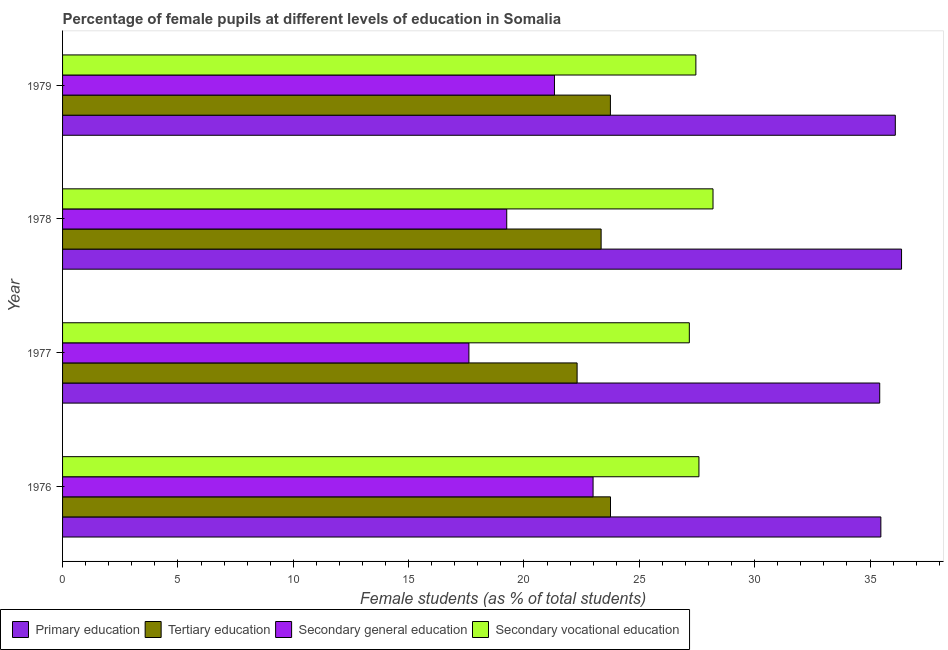How many different coloured bars are there?
Provide a short and direct response. 4. How many bars are there on the 3rd tick from the bottom?
Make the answer very short. 4. In how many cases, is the number of bars for a given year not equal to the number of legend labels?
Ensure brevity in your answer.  0. What is the percentage of female students in primary education in 1976?
Offer a very short reply. 35.47. Across all years, what is the maximum percentage of female students in primary education?
Give a very brief answer. 36.36. Across all years, what is the minimum percentage of female students in secondary vocational education?
Your answer should be compact. 27.17. In which year was the percentage of female students in primary education maximum?
Provide a succinct answer. 1978. What is the total percentage of female students in secondary vocational education in the graph?
Give a very brief answer. 110.39. What is the difference between the percentage of female students in secondary education in 1977 and that in 1979?
Your answer should be compact. -3.71. What is the difference between the percentage of female students in primary education in 1977 and the percentage of female students in tertiary education in 1976?
Keep it short and to the point. 11.67. What is the average percentage of female students in secondary education per year?
Offer a very short reply. 20.3. In the year 1976, what is the difference between the percentage of female students in secondary vocational education and percentage of female students in tertiary education?
Provide a succinct answer. 3.83. In how many years, is the percentage of female students in primary education greater than 26 %?
Your answer should be very brief. 4. What is the ratio of the percentage of female students in tertiary education in 1977 to that in 1978?
Provide a short and direct response. 0.95. Is the percentage of female students in primary education in 1977 less than that in 1978?
Provide a succinct answer. Yes. Is the difference between the percentage of female students in secondary education in 1976 and 1978 greater than the difference between the percentage of female students in secondary vocational education in 1976 and 1978?
Offer a terse response. Yes. What is the difference between the highest and the second highest percentage of female students in secondary vocational education?
Keep it short and to the point. 0.61. What is the difference between the highest and the lowest percentage of female students in secondary education?
Your response must be concise. 5.38. In how many years, is the percentage of female students in primary education greater than the average percentage of female students in primary education taken over all years?
Your response must be concise. 2. Is it the case that in every year, the sum of the percentage of female students in secondary education and percentage of female students in primary education is greater than the sum of percentage of female students in secondary vocational education and percentage of female students in tertiary education?
Keep it short and to the point. No. What does the 1st bar from the top in 1979 represents?
Ensure brevity in your answer.  Secondary vocational education. What does the 4th bar from the bottom in 1977 represents?
Provide a succinct answer. Secondary vocational education. How many years are there in the graph?
Keep it short and to the point. 4. What is the difference between two consecutive major ticks on the X-axis?
Provide a succinct answer. 5. Does the graph contain any zero values?
Your answer should be compact. No. Where does the legend appear in the graph?
Provide a succinct answer. Bottom left. How are the legend labels stacked?
Offer a terse response. Horizontal. What is the title of the graph?
Your response must be concise. Percentage of female pupils at different levels of education in Somalia. What is the label or title of the X-axis?
Provide a short and direct response. Female students (as % of total students). What is the Female students (as % of total students) in Primary education in 1976?
Give a very brief answer. 35.47. What is the Female students (as % of total students) of Tertiary education in 1976?
Make the answer very short. 23.75. What is the Female students (as % of total students) in Secondary general education in 1976?
Keep it short and to the point. 22.99. What is the Female students (as % of total students) in Secondary vocational education in 1976?
Offer a terse response. 27.58. What is the Female students (as % of total students) of Primary education in 1977?
Your answer should be very brief. 35.42. What is the Female students (as % of total students) of Tertiary education in 1977?
Ensure brevity in your answer.  22.3. What is the Female students (as % of total students) in Secondary general education in 1977?
Offer a very short reply. 17.61. What is the Female students (as % of total students) in Secondary vocational education in 1977?
Make the answer very short. 27.17. What is the Female students (as % of total students) in Primary education in 1978?
Give a very brief answer. 36.36. What is the Female students (as % of total students) of Tertiary education in 1978?
Your answer should be very brief. 23.34. What is the Female students (as % of total students) of Secondary general education in 1978?
Make the answer very short. 19.25. What is the Female students (as % of total students) in Secondary vocational education in 1978?
Your answer should be compact. 28.19. What is the Female students (as % of total students) of Primary education in 1979?
Give a very brief answer. 36.09. What is the Female students (as % of total students) in Tertiary education in 1979?
Provide a short and direct response. 23.75. What is the Female students (as % of total students) of Secondary general education in 1979?
Provide a short and direct response. 21.32. What is the Female students (as % of total students) of Secondary vocational education in 1979?
Provide a short and direct response. 27.45. Across all years, what is the maximum Female students (as % of total students) in Primary education?
Your answer should be compact. 36.36. Across all years, what is the maximum Female students (as % of total students) of Tertiary education?
Your answer should be very brief. 23.75. Across all years, what is the maximum Female students (as % of total students) of Secondary general education?
Provide a succinct answer. 22.99. Across all years, what is the maximum Female students (as % of total students) of Secondary vocational education?
Give a very brief answer. 28.19. Across all years, what is the minimum Female students (as % of total students) of Primary education?
Offer a very short reply. 35.42. Across all years, what is the minimum Female students (as % of total students) in Tertiary education?
Make the answer very short. 22.3. Across all years, what is the minimum Female students (as % of total students) of Secondary general education?
Your answer should be very brief. 17.61. Across all years, what is the minimum Female students (as % of total students) in Secondary vocational education?
Ensure brevity in your answer.  27.17. What is the total Female students (as % of total students) of Primary education in the graph?
Provide a succinct answer. 143.35. What is the total Female students (as % of total students) in Tertiary education in the graph?
Offer a terse response. 93.14. What is the total Female students (as % of total students) in Secondary general education in the graph?
Provide a succinct answer. 81.18. What is the total Female students (as % of total students) in Secondary vocational education in the graph?
Keep it short and to the point. 110.39. What is the difference between the Female students (as % of total students) of Primary education in 1976 and that in 1977?
Give a very brief answer. 0.05. What is the difference between the Female students (as % of total students) in Tertiary education in 1976 and that in 1977?
Offer a terse response. 1.45. What is the difference between the Female students (as % of total students) in Secondary general education in 1976 and that in 1977?
Provide a short and direct response. 5.38. What is the difference between the Female students (as % of total students) in Secondary vocational education in 1976 and that in 1977?
Your answer should be very brief. 0.42. What is the difference between the Female students (as % of total students) of Primary education in 1976 and that in 1978?
Your answer should be very brief. -0.9. What is the difference between the Female students (as % of total students) of Tertiary education in 1976 and that in 1978?
Provide a succinct answer. 0.41. What is the difference between the Female students (as % of total students) in Secondary general education in 1976 and that in 1978?
Your response must be concise. 3.74. What is the difference between the Female students (as % of total students) of Secondary vocational education in 1976 and that in 1978?
Your answer should be very brief. -0.61. What is the difference between the Female students (as % of total students) in Primary education in 1976 and that in 1979?
Give a very brief answer. -0.63. What is the difference between the Female students (as % of total students) in Tertiary education in 1976 and that in 1979?
Your response must be concise. 0. What is the difference between the Female students (as % of total students) of Secondary general education in 1976 and that in 1979?
Ensure brevity in your answer.  1.67. What is the difference between the Female students (as % of total students) in Secondary vocational education in 1976 and that in 1979?
Ensure brevity in your answer.  0.13. What is the difference between the Female students (as % of total students) in Primary education in 1977 and that in 1978?
Ensure brevity in your answer.  -0.95. What is the difference between the Female students (as % of total students) of Tertiary education in 1977 and that in 1978?
Give a very brief answer. -1.04. What is the difference between the Female students (as % of total students) in Secondary general education in 1977 and that in 1978?
Provide a short and direct response. -1.64. What is the difference between the Female students (as % of total students) of Secondary vocational education in 1977 and that in 1978?
Give a very brief answer. -1.03. What is the difference between the Female students (as % of total students) of Primary education in 1977 and that in 1979?
Make the answer very short. -0.68. What is the difference between the Female students (as % of total students) in Tertiary education in 1977 and that in 1979?
Provide a short and direct response. -1.44. What is the difference between the Female students (as % of total students) of Secondary general education in 1977 and that in 1979?
Offer a very short reply. -3.71. What is the difference between the Female students (as % of total students) in Secondary vocational education in 1977 and that in 1979?
Make the answer very short. -0.28. What is the difference between the Female students (as % of total students) of Primary education in 1978 and that in 1979?
Offer a very short reply. 0.27. What is the difference between the Female students (as % of total students) in Tertiary education in 1978 and that in 1979?
Ensure brevity in your answer.  -0.4. What is the difference between the Female students (as % of total students) in Secondary general education in 1978 and that in 1979?
Your answer should be compact. -2.07. What is the difference between the Female students (as % of total students) in Secondary vocational education in 1978 and that in 1979?
Keep it short and to the point. 0.74. What is the difference between the Female students (as % of total students) in Primary education in 1976 and the Female students (as % of total students) in Tertiary education in 1977?
Offer a very short reply. 13.17. What is the difference between the Female students (as % of total students) of Primary education in 1976 and the Female students (as % of total students) of Secondary general education in 1977?
Your answer should be very brief. 17.86. What is the difference between the Female students (as % of total students) of Primary education in 1976 and the Female students (as % of total students) of Secondary vocational education in 1977?
Ensure brevity in your answer.  8.3. What is the difference between the Female students (as % of total students) of Tertiary education in 1976 and the Female students (as % of total students) of Secondary general education in 1977?
Your response must be concise. 6.14. What is the difference between the Female students (as % of total students) in Tertiary education in 1976 and the Female students (as % of total students) in Secondary vocational education in 1977?
Give a very brief answer. -3.42. What is the difference between the Female students (as % of total students) in Secondary general education in 1976 and the Female students (as % of total students) in Secondary vocational education in 1977?
Make the answer very short. -4.17. What is the difference between the Female students (as % of total students) of Primary education in 1976 and the Female students (as % of total students) of Tertiary education in 1978?
Provide a short and direct response. 12.12. What is the difference between the Female students (as % of total students) of Primary education in 1976 and the Female students (as % of total students) of Secondary general education in 1978?
Make the answer very short. 16.22. What is the difference between the Female students (as % of total students) in Primary education in 1976 and the Female students (as % of total students) in Secondary vocational education in 1978?
Give a very brief answer. 7.27. What is the difference between the Female students (as % of total students) in Tertiary education in 1976 and the Female students (as % of total students) in Secondary general education in 1978?
Your answer should be very brief. 4.5. What is the difference between the Female students (as % of total students) in Tertiary education in 1976 and the Female students (as % of total students) in Secondary vocational education in 1978?
Offer a very short reply. -4.44. What is the difference between the Female students (as % of total students) in Secondary general education in 1976 and the Female students (as % of total students) in Secondary vocational education in 1978?
Give a very brief answer. -5.2. What is the difference between the Female students (as % of total students) of Primary education in 1976 and the Female students (as % of total students) of Tertiary education in 1979?
Your response must be concise. 11.72. What is the difference between the Female students (as % of total students) in Primary education in 1976 and the Female students (as % of total students) in Secondary general education in 1979?
Keep it short and to the point. 14.15. What is the difference between the Female students (as % of total students) in Primary education in 1976 and the Female students (as % of total students) in Secondary vocational education in 1979?
Keep it short and to the point. 8.02. What is the difference between the Female students (as % of total students) of Tertiary education in 1976 and the Female students (as % of total students) of Secondary general education in 1979?
Your answer should be very brief. 2.43. What is the difference between the Female students (as % of total students) in Tertiary education in 1976 and the Female students (as % of total students) in Secondary vocational education in 1979?
Offer a terse response. -3.7. What is the difference between the Female students (as % of total students) in Secondary general education in 1976 and the Female students (as % of total students) in Secondary vocational education in 1979?
Provide a succinct answer. -4.46. What is the difference between the Female students (as % of total students) of Primary education in 1977 and the Female students (as % of total students) of Tertiary education in 1978?
Make the answer very short. 12.08. What is the difference between the Female students (as % of total students) of Primary education in 1977 and the Female students (as % of total students) of Secondary general education in 1978?
Provide a short and direct response. 16.17. What is the difference between the Female students (as % of total students) in Primary education in 1977 and the Female students (as % of total students) in Secondary vocational education in 1978?
Your response must be concise. 7.23. What is the difference between the Female students (as % of total students) of Tertiary education in 1977 and the Female students (as % of total students) of Secondary general education in 1978?
Make the answer very short. 3.05. What is the difference between the Female students (as % of total students) in Tertiary education in 1977 and the Female students (as % of total students) in Secondary vocational education in 1978?
Offer a very short reply. -5.89. What is the difference between the Female students (as % of total students) in Secondary general education in 1977 and the Female students (as % of total students) in Secondary vocational education in 1978?
Your answer should be compact. -10.58. What is the difference between the Female students (as % of total students) in Primary education in 1977 and the Female students (as % of total students) in Tertiary education in 1979?
Offer a very short reply. 11.67. What is the difference between the Female students (as % of total students) of Primary education in 1977 and the Female students (as % of total students) of Secondary general education in 1979?
Provide a short and direct response. 14.1. What is the difference between the Female students (as % of total students) in Primary education in 1977 and the Female students (as % of total students) in Secondary vocational education in 1979?
Keep it short and to the point. 7.97. What is the difference between the Female students (as % of total students) in Tertiary education in 1977 and the Female students (as % of total students) in Secondary general education in 1979?
Provide a succinct answer. 0.98. What is the difference between the Female students (as % of total students) in Tertiary education in 1977 and the Female students (as % of total students) in Secondary vocational education in 1979?
Give a very brief answer. -5.15. What is the difference between the Female students (as % of total students) of Secondary general education in 1977 and the Female students (as % of total students) of Secondary vocational education in 1979?
Give a very brief answer. -9.84. What is the difference between the Female students (as % of total students) in Primary education in 1978 and the Female students (as % of total students) in Tertiary education in 1979?
Make the answer very short. 12.62. What is the difference between the Female students (as % of total students) of Primary education in 1978 and the Female students (as % of total students) of Secondary general education in 1979?
Ensure brevity in your answer.  15.04. What is the difference between the Female students (as % of total students) of Primary education in 1978 and the Female students (as % of total students) of Secondary vocational education in 1979?
Your answer should be very brief. 8.91. What is the difference between the Female students (as % of total students) of Tertiary education in 1978 and the Female students (as % of total students) of Secondary general education in 1979?
Give a very brief answer. 2.02. What is the difference between the Female students (as % of total students) in Tertiary education in 1978 and the Female students (as % of total students) in Secondary vocational education in 1979?
Provide a succinct answer. -4.11. What is the difference between the Female students (as % of total students) in Secondary general education in 1978 and the Female students (as % of total students) in Secondary vocational education in 1979?
Ensure brevity in your answer.  -8.2. What is the average Female students (as % of total students) in Primary education per year?
Make the answer very short. 35.84. What is the average Female students (as % of total students) in Tertiary education per year?
Offer a terse response. 23.29. What is the average Female students (as % of total students) of Secondary general education per year?
Offer a terse response. 20.3. What is the average Female students (as % of total students) of Secondary vocational education per year?
Make the answer very short. 27.6. In the year 1976, what is the difference between the Female students (as % of total students) of Primary education and Female students (as % of total students) of Tertiary education?
Keep it short and to the point. 11.72. In the year 1976, what is the difference between the Female students (as % of total students) in Primary education and Female students (as % of total students) in Secondary general education?
Offer a very short reply. 12.47. In the year 1976, what is the difference between the Female students (as % of total students) of Primary education and Female students (as % of total students) of Secondary vocational education?
Your response must be concise. 7.88. In the year 1976, what is the difference between the Female students (as % of total students) in Tertiary education and Female students (as % of total students) in Secondary general education?
Keep it short and to the point. 0.76. In the year 1976, what is the difference between the Female students (as % of total students) in Tertiary education and Female students (as % of total students) in Secondary vocational education?
Offer a terse response. -3.83. In the year 1976, what is the difference between the Female students (as % of total students) in Secondary general education and Female students (as % of total students) in Secondary vocational education?
Give a very brief answer. -4.59. In the year 1977, what is the difference between the Female students (as % of total students) in Primary education and Female students (as % of total students) in Tertiary education?
Provide a short and direct response. 13.12. In the year 1977, what is the difference between the Female students (as % of total students) of Primary education and Female students (as % of total students) of Secondary general education?
Give a very brief answer. 17.81. In the year 1977, what is the difference between the Female students (as % of total students) of Primary education and Female students (as % of total students) of Secondary vocational education?
Offer a terse response. 8.25. In the year 1977, what is the difference between the Female students (as % of total students) in Tertiary education and Female students (as % of total students) in Secondary general education?
Your answer should be very brief. 4.69. In the year 1977, what is the difference between the Female students (as % of total students) in Tertiary education and Female students (as % of total students) in Secondary vocational education?
Keep it short and to the point. -4.86. In the year 1977, what is the difference between the Female students (as % of total students) of Secondary general education and Female students (as % of total students) of Secondary vocational education?
Your answer should be compact. -9.55. In the year 1978, what is the difference between the Female students (as % of total students) in Primary education and Female students (as % of total students) in Tertiary education?
Provide a short and direct response. 13.02. In the year 1978, what is the difference between the Female students (as % of total students) in Primary education and Female students (as % of total students) in Secondary general education?
Keep it short and to the point. 17.11. In the year 1978, what is the difference between the Female students (as % of total students) of Primary education and Female students (as % of total students) of Secondary vocational education?
Make the answer very short. 8.17. In the year 1978, what is the difference between the Female students (as % of total students) of Tertiary education and Female students (as % of total students) of Secondary general education?
Offer a terse response. 4.09. In the year 1978, what is the difference between the Female students (as % of total students) in Tertiary education and Female students (as % of total students) in Secondary vocational education?
Ensure brevity in your answer.  -4.85. In the year 1978, what is the difference between the Female students (as % of total students) of Secondary general education and Female students (as % of total students) of Secondary vocational education?
Ensure brevity in your answer.  -8.94. In the year 1979, what is the difference between the Female students (as % of total students) of Primary education and Female students (as % of total students) of Tertiary education?
Your answer should be compact. 12.35. In the year 1979, what is the difference between the Female students (as % of total students) in Primary education and Female students (as % of total students) in Secondary general education?
Offer a terse response. 14.77. In the year 1979, what is the difference between the Female students (as % of total students) in Primary education and Female students (as % of total students) in Secondary vocational education?
Give a very brief answer. 8.64. In the year 1979, what is the difference between the Female students (as % of total students) in Tertiary education and Female students (as % of total students) in Secondary general education?
Provide a short and direct response. 2.42. In the year 1979, what is the difference between the Female students (as % of total students) in Tertiary education and Female students (as % of total students) in Secondary vocational education?
Keep it short and to the point. -3.7. In the year 1979, what is the difference between the Female students (as % of total students) in Secondary general education and Female students (as % of total students) in Secondary vocational education?
Provide a succinct answer. -6.13. What is the ratio of the Female students (as % of total students) of Primary education in 1976 to that in 1977?
Your response must be concise. 1. What is the ratio of the Female students (as % of total students) in Tertiary education in 1976 to that in 1977?
Your response must be concise. 1.06. What is the ratio of the Female students (as % of total students) in Secondary general education in 1976 to that in 1977?
Give a very brief answer. 1.31. What is the ratio of the Female students (as % of total students) of Secondary vocational education in 1976 to that in 1977?
Provide a succinct answer. 1.02. What is the ratio of the Female students (as % of total students) in Primary education in 1976 to that in 1978?
Provide a short and direct response. 0.98. What is the ratio of the Female students (as % of total students) in Tertiary education in 1976 to that in 1978?
Make the answer very short. 1.02. What is the ratio of the Female students (as % of total students) of Secondary general education in 1976 to that in 1978?
Offer a very short reply. 1.19. What is the ratio of the Female students (as % of total students) in Secondary vocational education in 1976 to that in 1978?
Your response must be concise. 0.98. What is the ratio of the Female students (as % of total students) of Primary education in 1976 to that in 1979?
Keep it short and to the point. 0.98. What is the ratio of the Female students (as % of total students) in Tertiary education in 1976 to that in 1979?
Offer a very short reply. 1. What is the ratio of the Female students (as % of total students) of Secondary general education in 1976 to that in 1979?
Provide a short and direct response. 1.08. What is the ratio of the Female students (as % of total students) in Primary education in 1977 to that in 1978?
Keep it short and to the point. 0.97. What is the ratio of the Female students (as % of total students) in Tertiary education in 1977 to that in 1978?
Ensure brevity in your answer.  0.96. What is the ratio of the Female students (as % of total students) of Secondary general education in 1977 to that in 1978?
Provide a short and direct response. 0.91. What is the ratio of the Female students (as % of total students) of Secondary vocational education in 1977 to that in 1978?
Your answer should be compact. 0.96. What is the ratio of the Female students (as % of total students) of Primary education in 1977 to that in 1979?
Make the answer very short. 0.98. What is the ratio of the Female students (as % of total students) of Tertiary education in 1977 to that in 1979?
Offer a very short reply. 0.94. What is the ratio of the Female students (as % of total students) of Secondary general education in 1977 to that in 1979?
Give a very brief answer. 0.83. What is the ratio of the Female students (as % of total students) in Secondary vocational education in 1977 to that in 1979?
Your answer should be very brief. 0.99. What is the ratio of the Female students (as % of total students) of Primary education in 1978 to that in 1979?
Give a very brief answer. 1.01. What is the ratio of the Female students (as % of total students) in Tertiary education in 1978 to that in 1979?
Ensure brevity in your answer.  0.98. What is the ratio of the Female students (as % of total students) in Secondary general education in 1978 to that in 1979?
Provide a succinct answer. 0.9. What is the ratio of the Female students (as % of total students) in Secondary vocational education in 1978 to that in 1979?
Keep it short and to the point. 1.03. What is the difference between the highest and the second highest Female students (as % of total students) of Primary education?
Ensure brevity in your answer.  0.27. What is the difference between the highest and the second highest Female students (as % of total students) of Tertiary education?
Keep it short and to the point. 0. What is the difference between the highest and the second highest Female students (as % of total students) of Secondary general education?
Ensure brevity in your answer.  1.67. What is the difference between the highest and the second highest Female students (as % of total students) of Secondary vocational education?
Your response must be concise. 0.61. What is the difference between the highest and the lowest Female students (as % of total students) of Primary education?
Your answer should be compact. 0.95. What is the difference between the highest and the lowest Female students (as % of total students) of Tertiary education?
Make the answer very short. 1.45. What is the difference between the highest and the lowest Female students (as % of total students) in Secondary general education?
Give a very brief answer. 5.38. What is the difference between the highest and the lowest Female students (as % of total students) in Secondary vocational education?
Offer a terse response. 1.03. 